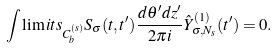Convert formula to latex. <formula><loc_0><loc_0><loc_500><loc_500>\int \lim i t s _ { C _ { b } ^ { ( s ) } } S _ { \sigma } ( t , t ^ { \prime } ) \frac { d \theta ^ { \prime } d z ^ { \prime } } { 2 \pi i } \hat { Y } _ { \sigma , N _ { s } } ^ { ( 1 ) } ( t ^ { \prime } ) = 0 .</formula> 